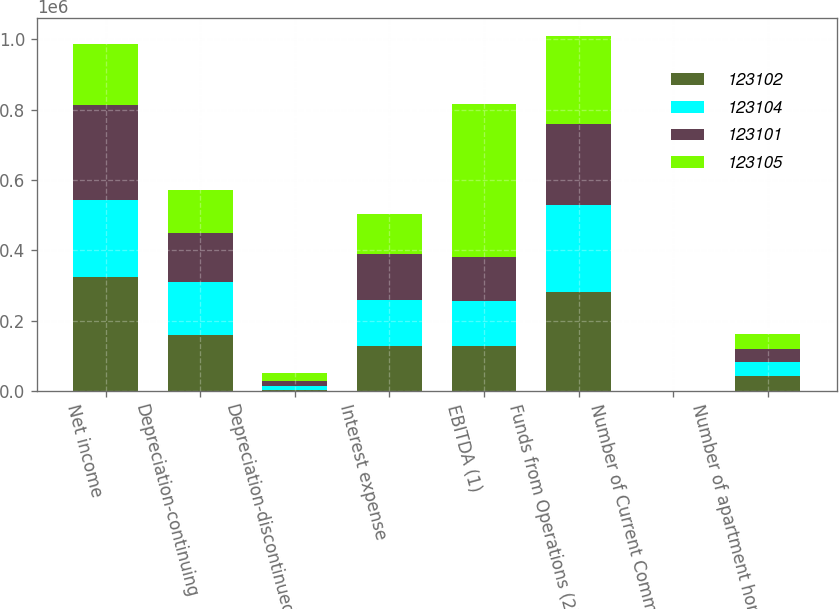Convert chart. <chart><loc_0><loc_0><loc_500><loc_500><stacked_bar_chart><ecel><fcel>Net income<fcel>Depreciation-continuing<fcel>Depreciation-discontinued<fcel>Interest expense<fcel>EBITDA (1)<fcel>Funds from Operations (2)<fcel>Number of Current Communities<fcel>Number of apartment homes<nl><fcel>123102<fcel>322378<fcel>158822<fcel>3241<fcel>127099<fcel>127099<fcel>281773<fcel>143<fcel>41412<nl><fcel>123104<fcel>219745<fcel>151991<fcel>10676<fcel>131103<fcel>127099<fcel>246247<fcel>138<fcel>40142<nl><fcel>123101<fcel>271525<fcel>138725<fcel>15071<fcel>130178<fcel>127099<fcel>230566<fcel>131<fcel>38504<nl><fcel>123105<fcel>173618<fcel>121995<fcel>22482<fcel>114282<fcel>435499<fcel>251410<fcel>137<fcel>40179<nl></chart> 